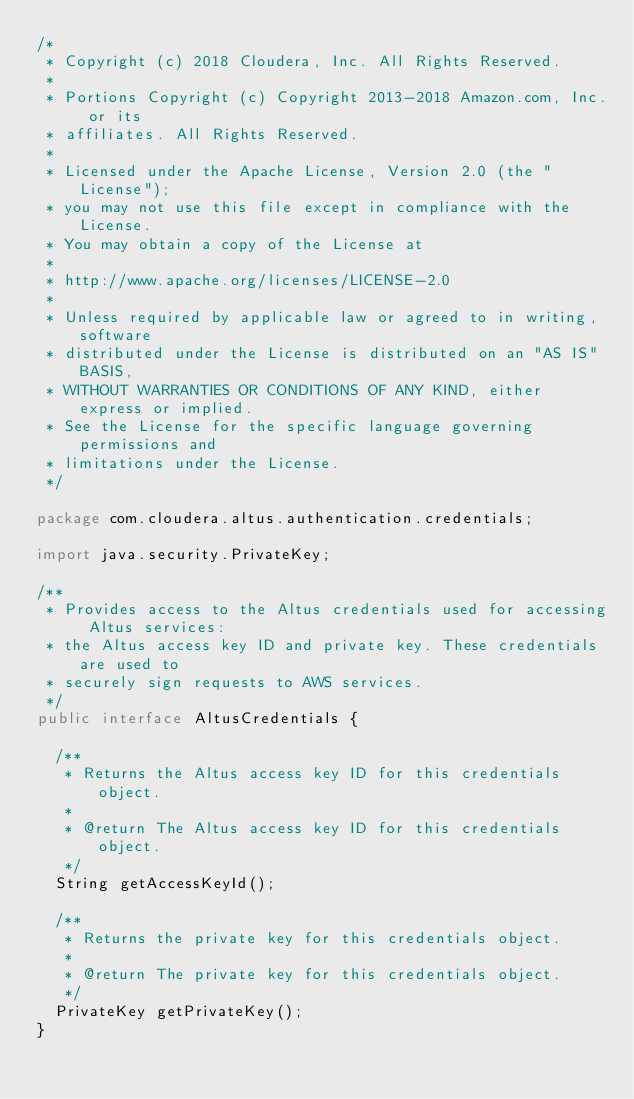<code> <loc_0><loc_0><loc_500><loc_500><_Java_>/*
 * Copyright (c) 2018 Cloudera, Inc. All Rights Reserved.
 *
 * Portions Copyright (c) Copyright 2013-2018 Amazon.com, Inc. or its
 * affiliates. All Rights Reserved.
 *
 * Licensed under the Apache License, Version 2.0 (the "License");
 * you may not use this file except in compliance with the License.
 * You may obtain a copy of the License at
 *
 * http://www.apache.org/licenses/LICENSE-2.0
 *
 * Unless required by applicable law or agreed to in writing, software
 * distributed under the License is distributed on an "AS IS" BASIS,
 * WITHOUT WARRANTIES OR CONDITIONS OF ANY KIND, either express or implied.
 * See the License for the specific language governing permissions and
 * limitations under the License.
 */

package com.cloudera.altus.authentication.credentials;

import java.security.PrivateKey;

/**
 * Provides access to the Altus credentials used for accessing Altus services:
 * the Altus access key ID and private key. These credentials are used to
 * securely sign requests to AWS services.
 */
public interface AltusCredentials {

  /**
   * Returns the Altus access key ID for this credentials object.
   *
   * @return The Altus access key ID for this credentials object.
   */
  String getAccessKeyId();

  /**
   * Returns the private key for this credentials object.
   *
   * @return The private key for this credentials object.
   */
  PrivateKey getPrivateKey();
}
</code> 